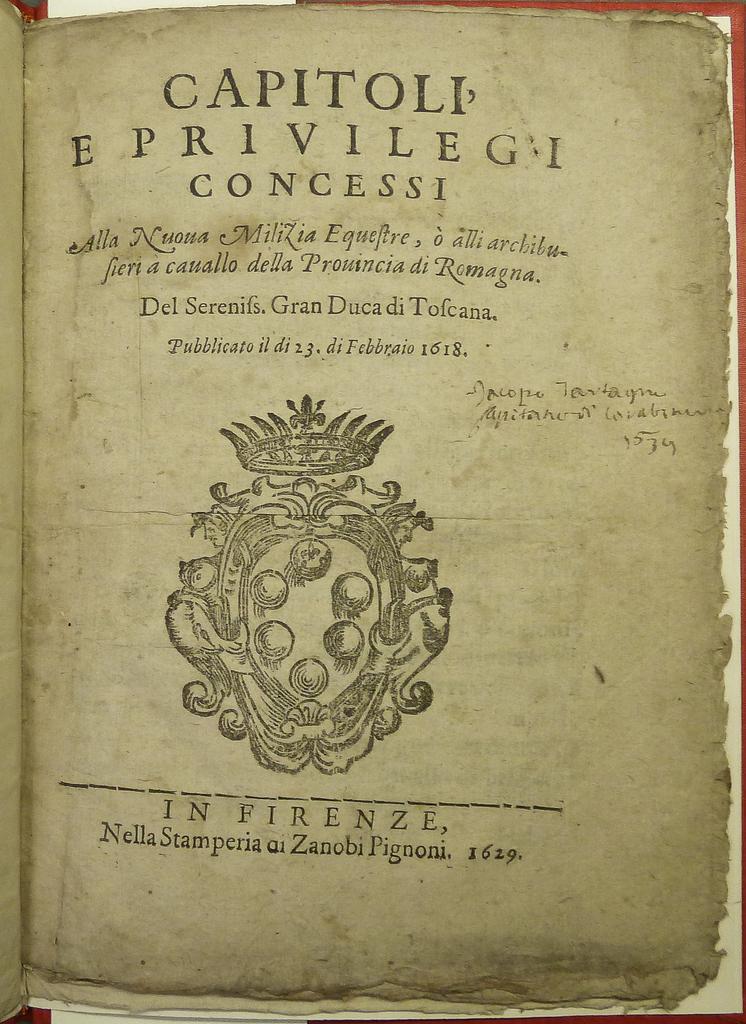What is the first word on the book?
Offer a terse response. Capitoli. What year is on the bottom of the page?
Provide a short and direct response. 1629. 